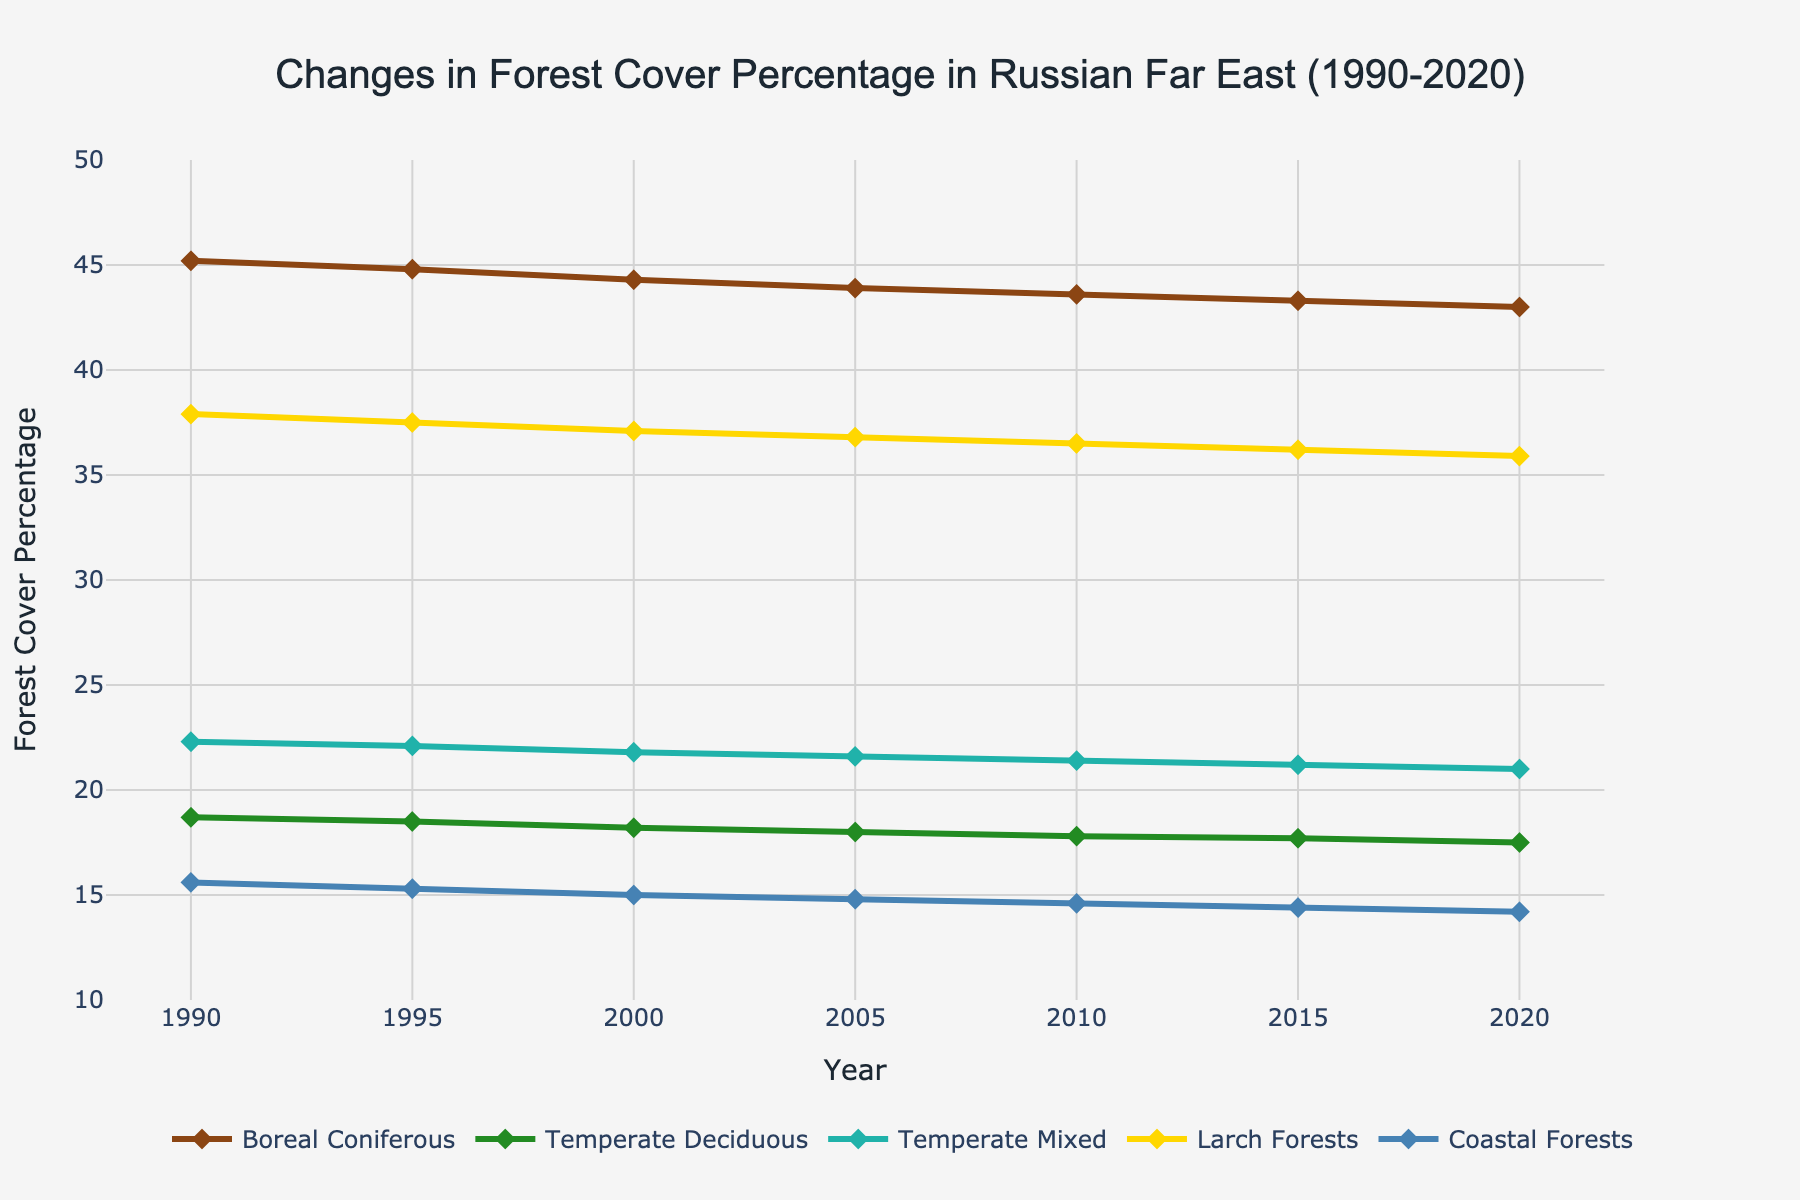What is the percentage of Boreal Coniferous forest cover in 1990 and 2020? Boreal Coniferous forest cover was 45.2% in 1990 and decreased to 43.0% in 2020, as shown in the plot's lines and markers for these years.
Answer: 45.2% in 1990 and 43.0% in 2020 Which forest type has the highest cover percentage in 2020? The plot shows five types of forests. In 2020, Boreal Coniferous forests have the highest cover percentage, noted by the highest line on the y-axis.
Answer: Boreal Coniferous How did the forest cover percentage of Temperate Deciduous forests change from 1990 to 2020? The Temperate Deciduous forest cover decreased from 18.7% in 1990 to 17.5% in 2020, as indicated by the downward slope of the respective line.
Answer: Decreased by 1.2% Which forest type shows the smallest decrease in cover percentage from 1990 to 2020? By comparing the decline in each forest type, Coastal Forests dropped from 15.6% to 14.2%, which is a decrease of 1.4%, the smallest among all types.
Answer: Coastal Forests What is the difference in forest cover percentage between Larch Forests and Coastal Forests in 2000? In 2000, Larch Forests had a cover percentage of 37.1% and Coastal Forests had 15.0%. The difference is calculated as 37.1% - 15.0% = 22.1%.
Answer: 22.1% Between which years did Temperate Mixed forests show the most significant decline in cover percentage? The most significant drop for Temperate Mixed forests occurs between 1990 and 1995, from 22.3% to 22.1%, as observed in the plot. Even though 0.2% is small, the trend here is a consistent decline overall but notable initially.
Answer: 1990-1995 What is the average cover percentage of Larch Forests from 1990 to 2020? Sum up the cover percentages from each year and divide by the number of years: (37.9 + 37.5 + 37.1 + 36.8 + 36.5 + 36.2 + 35.9) / 7 = 36.83%.
Answer: 36.83% How do the cover percentages of Temperate Deciduous and Temperate Mixed forests compare in 2010? In 2010, Temperate Deciduous forests had a cover percentage of 17.8%, while Temperate Mixed forests had 21.4%. Temperate Mixed forests have a higher percentage.
Answer: Temperate Mixed is higher Which forest type consistently shows the lowest cover percentage from 1990 to 2020? Coastal Forests have the lowest cover percentage consistently across all years, as indicated by the line located lowest on the graph.
Answer: Coastal Forests 